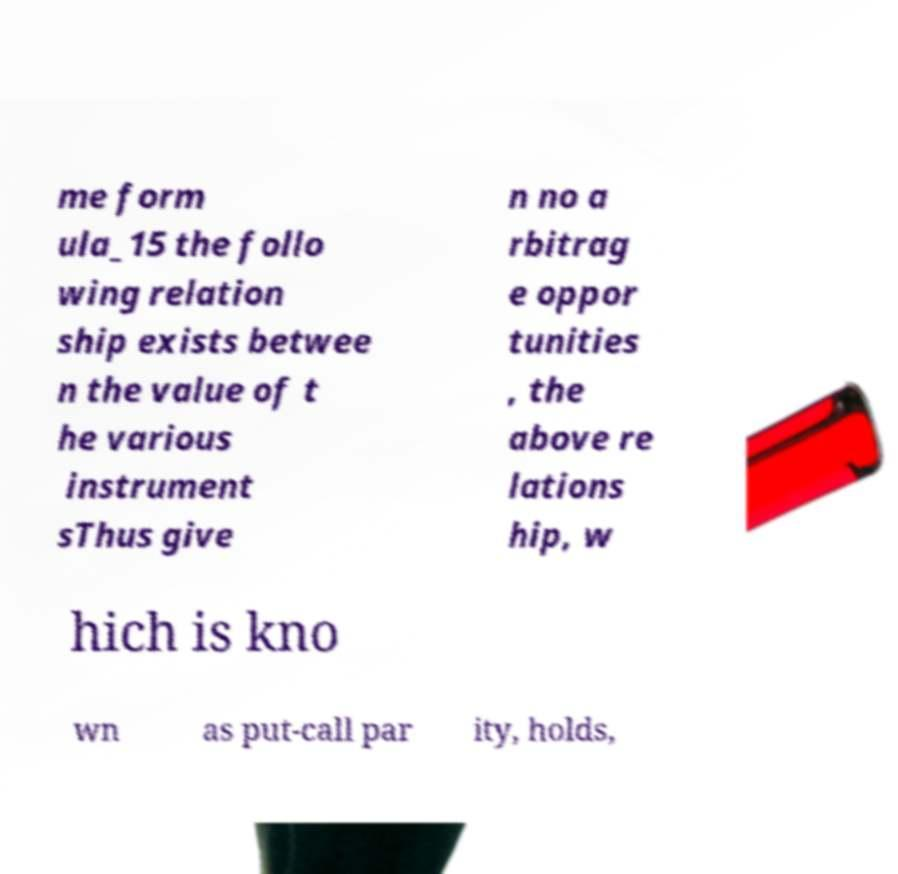Could you assist in decoding the text presented in this image and type it out clearly? me form ula_15 the follo wing relation ship exists betwee n the value of t he various instrument sThus give n no a rbitrag e oppor tunities , the above re lations hip, w hich is kno wn as put-call par ity, holds, 